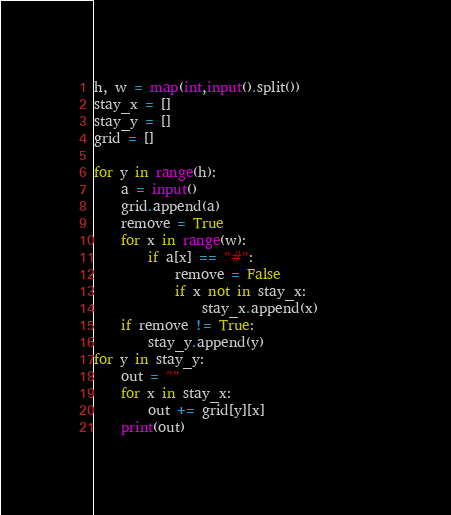<code> <loc_0><loc_0><loc_500><loc_500><_Python_>h, w = map(int,input().split())
stay_x = []
stay_y = []
grid = []

for y in range(h):
    a = input()
    grid.append(a)
    remove = True
    for x in range(w):
        if a[x] == "#":
            remove = False
            if x not in stay_x:
                stay_x.append(x)        
    if remove != True:
        stay_y.append(y)
for y in stay_y:
    out = ""
    for x in stay_x:
        out += grid[y][x]
    print(out)</code> 